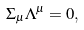Convert formula to latex. <formula><loc_0><loc_0><loc_500><loc_500>\Sigma _ { \mu } \Lambda ^ { \mu } = 0 ,</formula> 